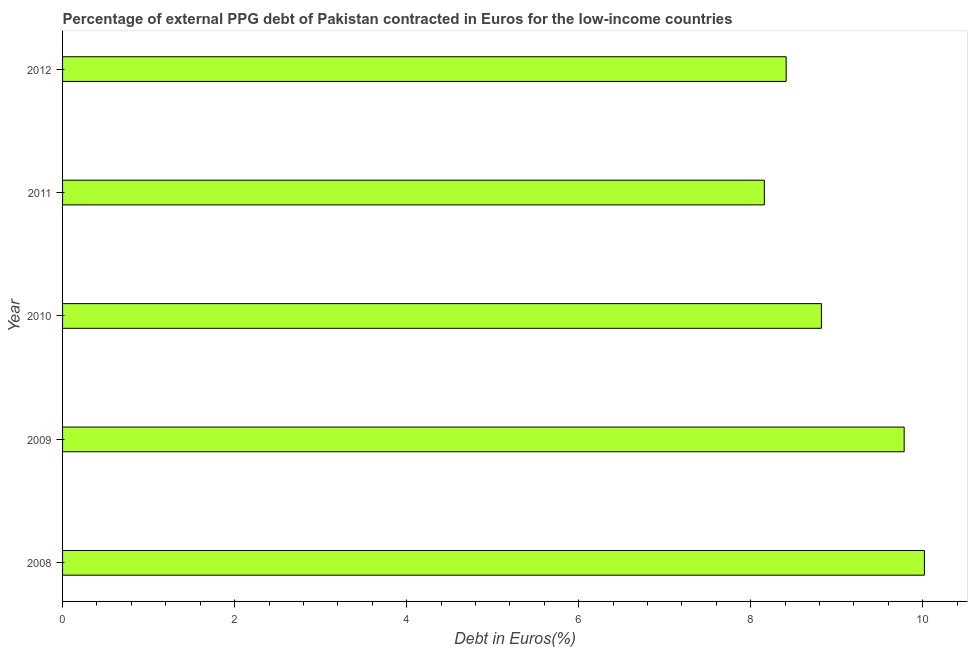Does the graph contain any zero values?
Your answer should be very brief. No. Does the graph contain grids?
Provide a short and direct response. No. What is the title of the graph?
Your answer should be very brief. Percentage of external PPG debt of Pakistan contracted in Euros for the low-income countries. What is the label or title of the X-axis?
Your answer should be compact. Debt in Euros(%). What is the currency composition of ppg debt in 2011?
Your answer should be compact. 8.16. Across all years, what is the maximum currency composition of ppg debt?
Provide a succinct answer. 10.02. Across all years, what is the minimum currency composition of ppg debt?
Ensure brevity in your answer.  8.16. In which year was the currency composition of ppg debt maximum?
Your response must be concise. 2008. In which year was the currency composition of ppg debt minimum?
Your answer should be compact. 2011. What is the sum of the currency composition of ppg debt?
Your response must be concise. 45.2. What is the difference between the currency composition of ppg debt in 2009 and 2010?
Offer a terse response. 0.96. What is the average currency composition of ppg debt per year?
Your answer should be compact. 9.04. What is the median currency composition of ppg debt?
Provide a succinct answer. 8.82. Do a majority of the years between 2008 and 2009 (inclusive) have currency composition of ppg debt greater than 2.8 %?
Offer a terse response. Yes. Is the currency composition of ppg debt in 2008 less than that in 2011?
Make the answer very short. No. What is the difference between the highest and the second highest currency composition of ppg debt?
Make the answer very short. 0.23. What is the difference between the highest and the lowest currency composition of ppg debt?
Ensure brevity in your answer.  1.86. In how many years, is the currency composition of ppg debt greater than the average currency composition of ppg debt taken over all years?
Make the answer very short. 2. Are all the bars in the graph horizontal?
Ensure brevity in your answer.  Yes. Are the values on the major ticks of X-axis written in scientific E-notation?
Your response must be concise. No. What is the Debt in Euros(%) in 2008?
Offer a terse response. 10.02. What is the Debt in Euros(%) in 2009?
Provide a succinct answer. 9.78. What is the Debt in Euros(%) in 2010?
Offer a terse response. 8.82. What is the Debt in Euros(%) in 2011?
Give a very brief answer. 8.16. What is the Debt in Euros(%) in 2012?
Your response must be concise. 8.41. What is the difference between the Debt in Euros(%) in 2008 and 2009?
Provide a succinct answer. 0.24. What is the difference between the Debt in Euros(%) in 2008 and 2010?
Ensure brevity in your answer.  1.2. What is the difference between the Debt in Euros(%) in 2008 and 2011?
Your answer should be compact. 1.86. What is the difference between the Debt in Euros(%) in 2008 and 2012?
Your answer should be very brief. 1.61. What is the difference between the Debt in Euros(%) in 2009 and 2010?
Keep it short and to the point. 0.96. What is the difference between the Debt in Euros(%) in 2009 and 2011?
Keep it short and to the point. 1.63. What is the difference between the Debt in Euros(%) in 2009 and 2012?
Offer a very short reply. 1.37. What is the difference between the Debt in Euros(%) in 2010 and 2011?
Give a very brief answer. 0.66. What is the difference between the Debt in Euros(%) in 2010 and 2012?
Your answer should be compact. 0.41. What is the difference between the Debt in Euros(%) in 2011 and 2012?
Offer a very short reply. -0.25. What is the ratio of the Debt in Euros(%) in 2008 to that in 2010?
Make the answer very short. 1.14. What is the ratio of the Debt in Euros(%) in 2008 to that in 2011?
Offer a terse response. 1.23. What is the ratio of the Debt in Euros(%) in 2008 to that in 2012?
Offer a terse response. 1.19. What is the ratio of the Debt in Euros(%) in 2009 to that in 2010?
Keep it short and to the point. 1.11. What is the ratio of the Debt in Euros(%) in 2009 to that in 2011?
Your response must be concise. 1.2. What is the ratio of the Debt in Euros(%) in 2009 to that in 2012?
Your answer should be compact. 1.16. What is the ratio of the Debt in Euros(%) in 2010 to that in 2011?
Your answer should be compact. 1.08. What is the ratio of the Debt in Euros(%) in 2010 to that in 2012?
Offer a very short reply. 1.05. What is the ratio of the Debt in Euros(%) in 2011 to that in 2012?
Keep it short and to the point. 0.97. 